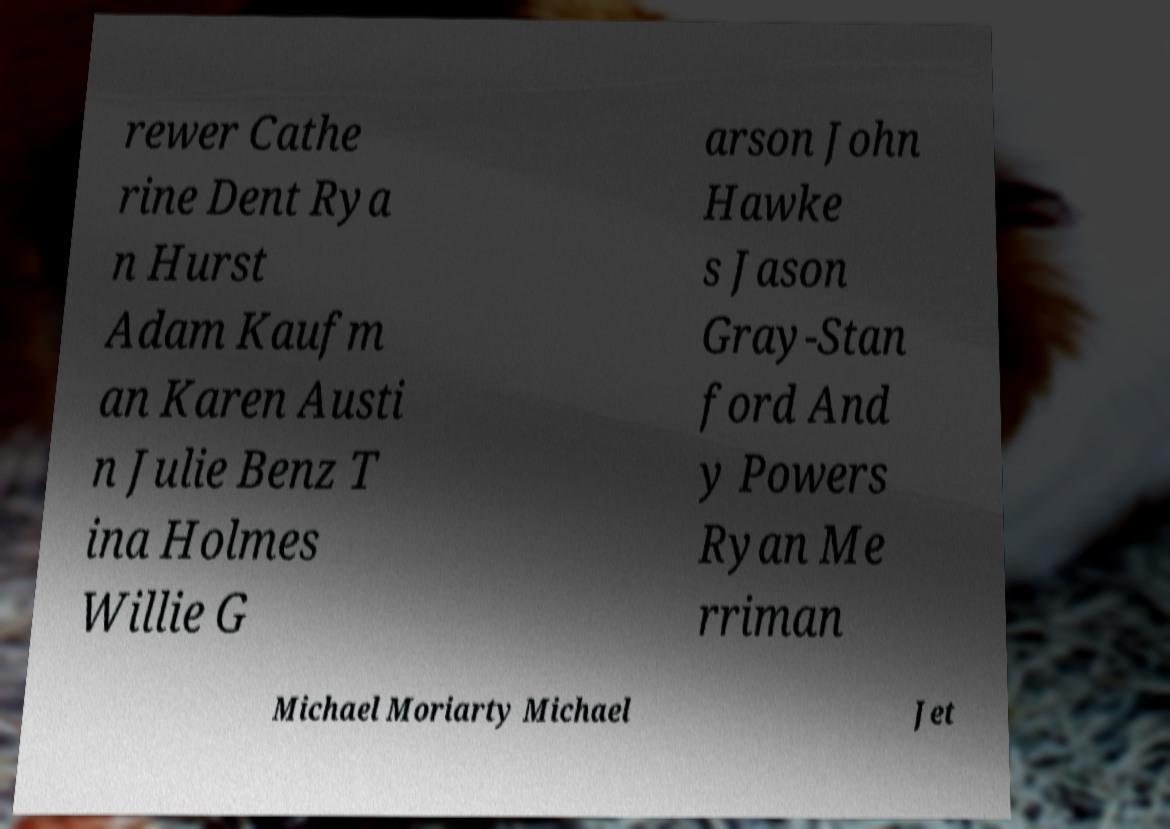Please identify and transcribe the text found in this image. rewer Cathe rine Dent Rya n Hurst Adam Kaufm an Karen Austi n Julie Benz T ina Holmes Willie G arson John Hawke s Jason Gray-Stan ford And y Powers Ryan Me rriman Michael Moriarty Michael Jet 